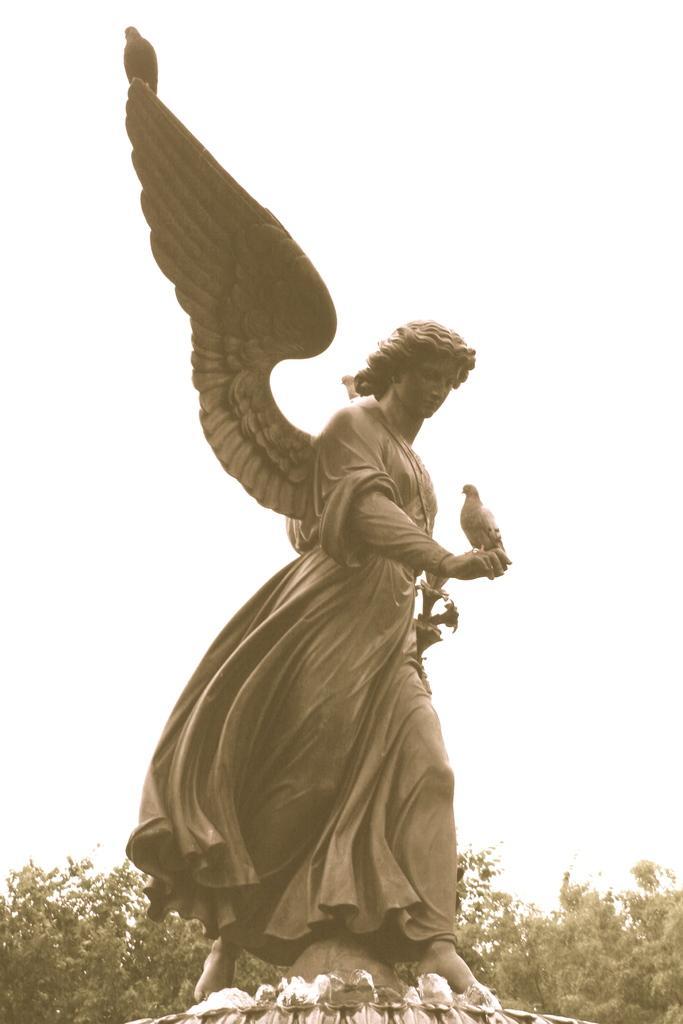In one or two sentences, can you explain what this image depicts? In this image we can see the statue of a person with wings and there is a bird on the statue. In the background we can see the sky and at the bottom we can see trees. 